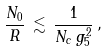Convert formula to latex. <formula><loc_0><loc_0><loc_500><loc_500>\frac { N _ { 0 } } { R } \, \lesssim \, \frac { 1 } { N _ { c } \, g _ { 5 } ^ { 2 } } \, ,</formula> 